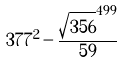<formula> <loc_0><loc_0><loc_500><loc_500>3 7 7 ^ { 2 } - \frac { \sqrt { 3 5 6 } ^ { 4 9 9 } } { 5 9 }</formula> 